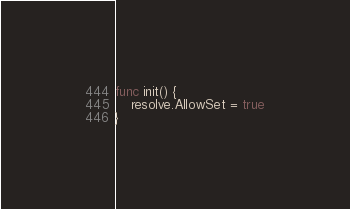Convert code to text. <code><loc_0><loc_0><loc_500><loc_500><_Go_>func init() {
	resolve.AllowSet = true
}
</code> 